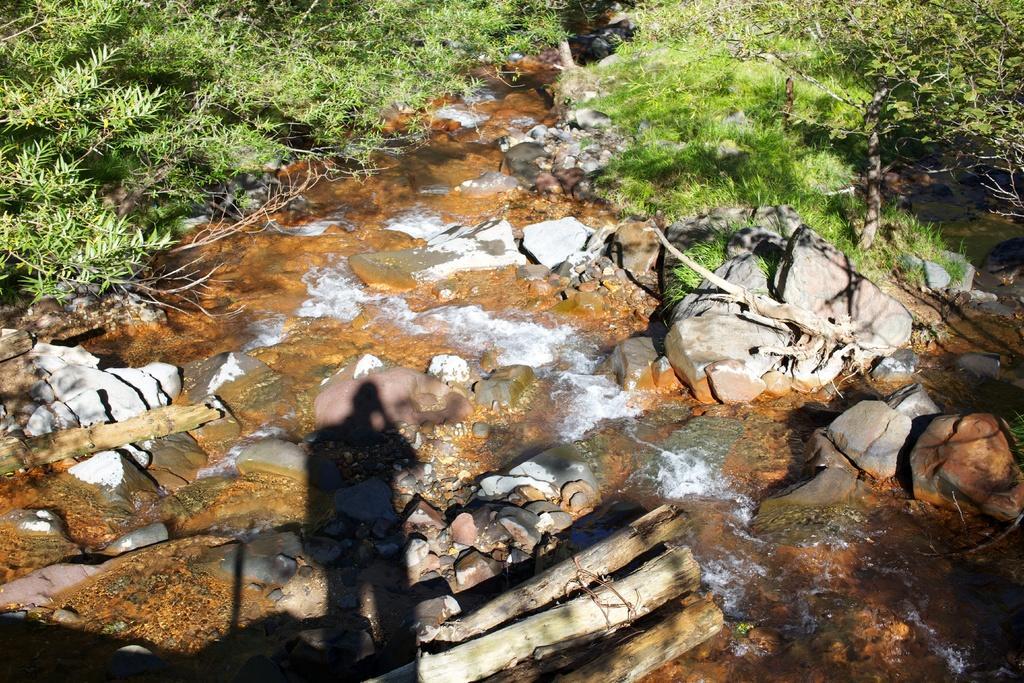How would you summarize this image in a sentence or two? In this image we can see flowing water, rocks, stones, logs, grass and trees. 